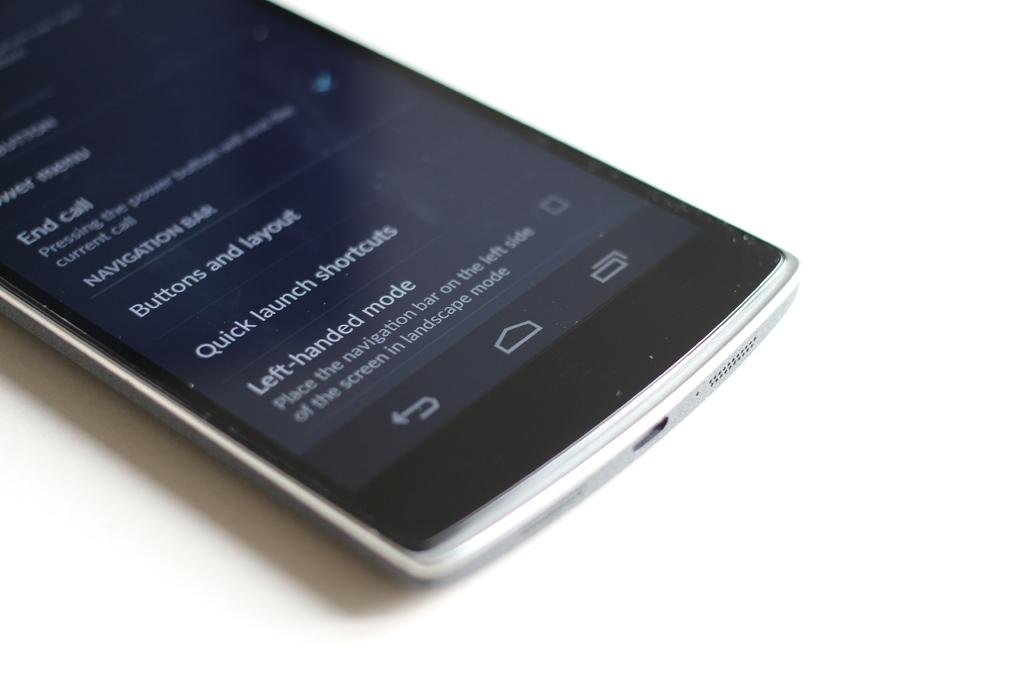<image>
Offer a succinct explanation of the picture presented. Phone that says "Left -handed mode" near the bottom. 